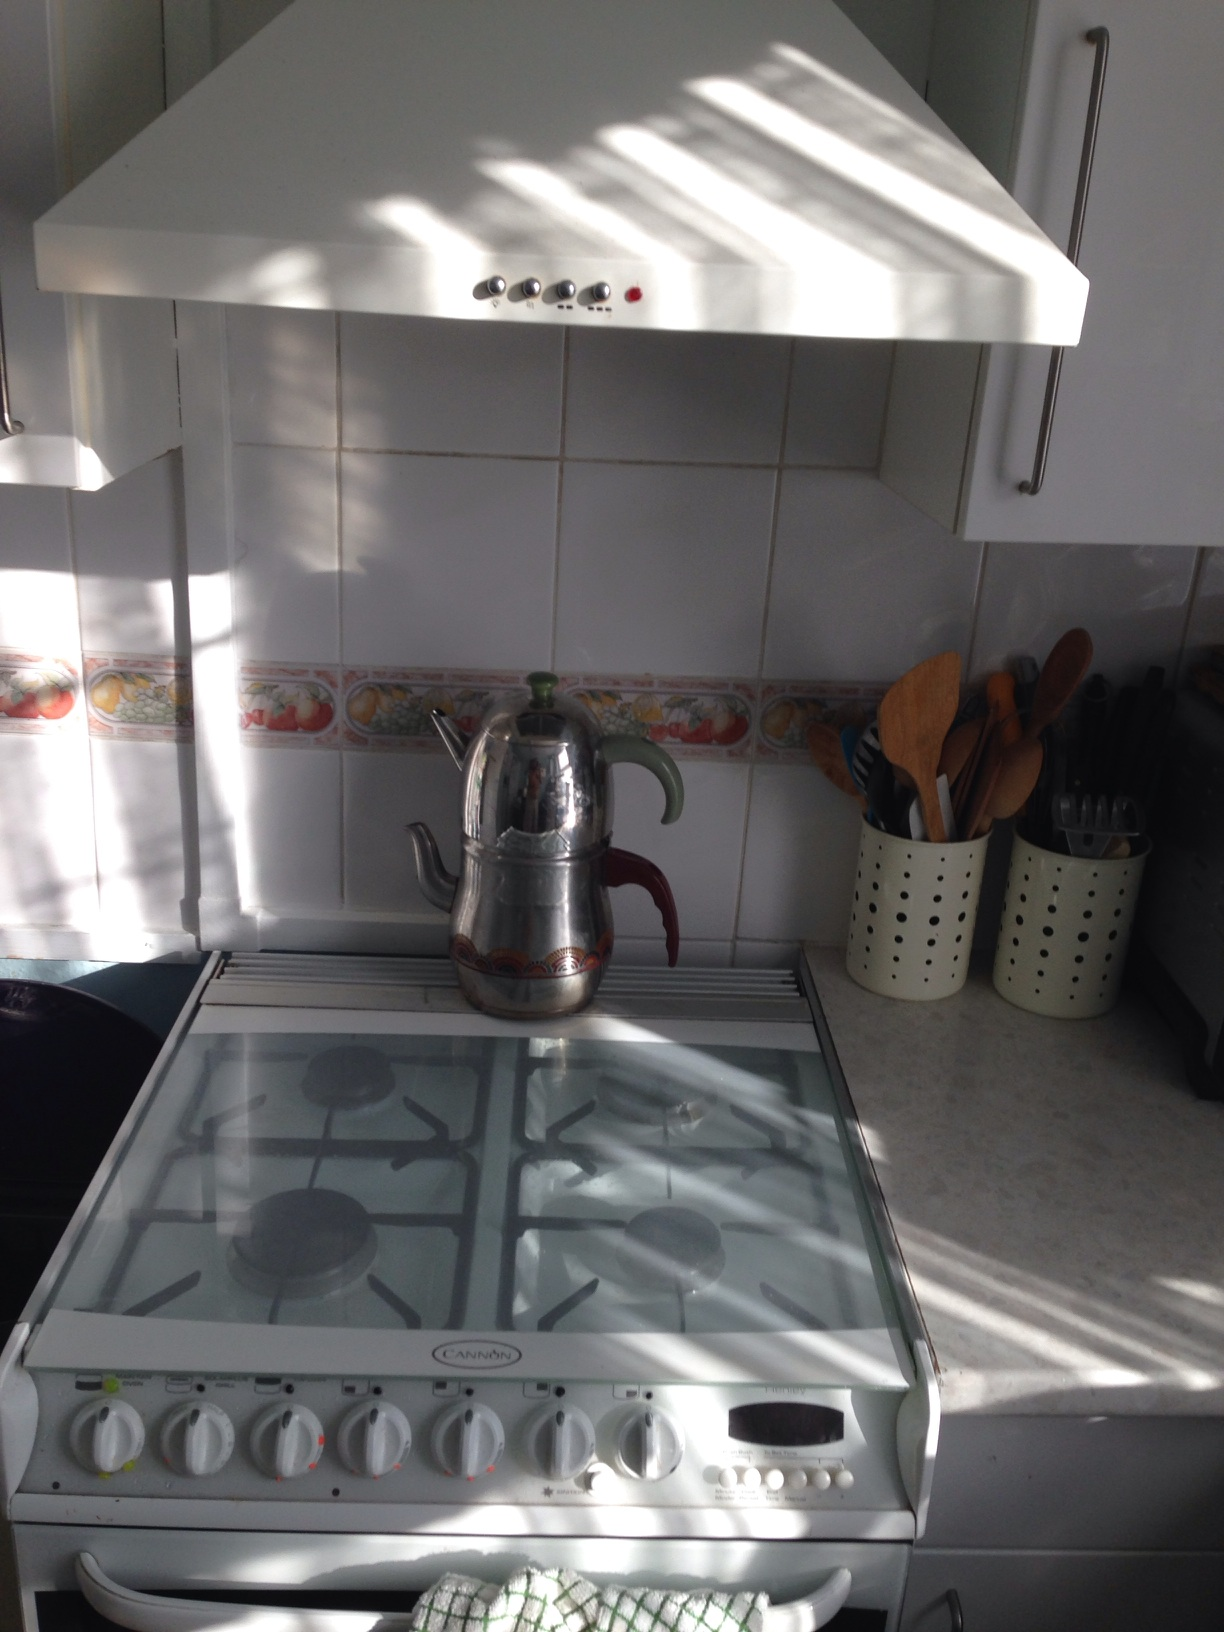What's a realistic scenario of someone using this kitchen for a short duration? A realistic scenario could involve someone boiling a pot of tea in the teapot seen on the stove. They might be using the wooden utensils on the counter to prepare a quick breakfast, such as scrambling eggs or flipping pancakes. 